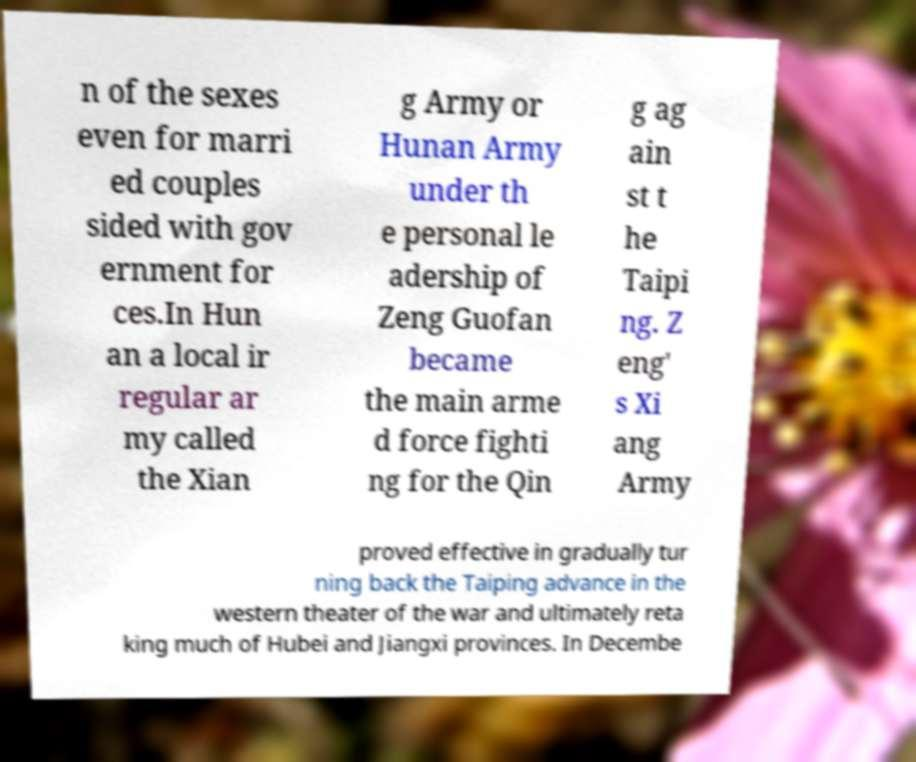Can you read and provide the text displayed in the image?This photo seems to have some interesting text. Can you extract and type it out for me? n of the sexes even for marri ed couples sided with gov ernment for ces.In Hun an a local ir regular ar my called the Xian g Army or Hunan Army under th e personal le adership of Zeng Guofan became the main arme d force fighti ng for the Qin g ag ain st t he Taipi ng. Z eng' s Xi ang Army proved effective in gradually tur ning back the Taiping advance in the western theater of the war and ultimately reta king much of Hubei and Jiangxi provinces. In Decembe 